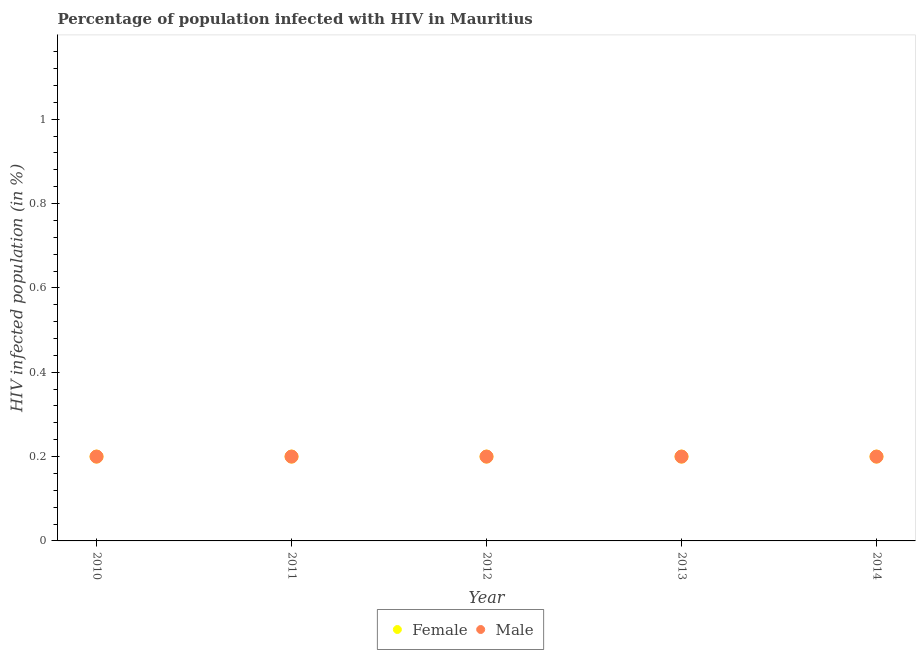Is the number of dotlines equal to the number of legend labels?
Offer a terse response. Yes. Across all years, what is the minimum percentage of females who are infected with hiv?
Provide a succinct answer. 0.2. What is the difference between the percentage of males who are infected with hiv in 2010 and the percentage of females who are infected with hiv in 2012?
Make the answer very short. 0. What is the average percentage of males who are infected with hiv per year?
Provide a succinct answer. 0.2. What is the ratio of the percentage of females who are infected with hiv in 2011 to that in 2014?
Offer a very short reply. 1. Is the percentage of females who are infected with hiv in 2011 less than that in 2014?
Offer a very short reply. No. What is the difference between the highest and the second highest percentage of males who are infected with hiv?
Provide a short and direct response. 0. Is the percentage of females who are infected with hiv strictly less than the percentage of males who are infected with hiv over the years?
Your answer should be very brief. No. How many dotlines are there?
Your answer should be very brief. 2. Are the values on the major ticks of Y-axis written in scientific E-notation?
Give a very brief answer. No. Does the graph contain grids?
Offer a very short reply. No. Where does the legend appear in the graph?
Keep it short and to the point. Bottom center. What is the title of the graph?
Offer a terse response. Percentage of population infected with HIV in Mauritius. Does "2012 US$" appear as one of the legend labels in the graph?
Your answer should be compact. No. What is the label or title of the Y-axis?
Make the answer very short. HIV infected population (in %). What is the HIV infected population (in %) in Female in 2010?
Provide a short and direct response. 0.2. What is the HIV infected population (in %) in Male in 2010?
Provide a succinct answer. 0.2. What is the HIV infected population (in %) of Male in 2011?
Give a very brief answer. 0.2. What is the HIV infected population (in %) in Female in 2012?
Keep it short and to the point. 0.2. What is the HIV infected population (in %) in Male in 2012?
Your response must be concise. 0.2. What is the HIV infected population (in %) in Male in 2014?
Keep it short and to the point. 0.2. Across all years, what is the maximum HIV infected population (in %) in Female?
Your answer should be compact. 0.2. Across all years, what is the maximum HIV infected population (in %) in Male?
Ensure brevity in your answer.  0.2. Across all years, what is the minimum HIV infected population (in %) in Female?
Provide a short and direct response. 0.2. Across all years, what is the minimum HIV infected population (in %) of Male?
Provide a succinct answer. 0.2. What is the total HIV infected population (in %) of Female in the graph?
Ensure brevity in your answer.  1. What is the difference between the HIV infected population (in %) of Female in 2010 and that in 2013?
Give a very brief answer. 0. What is the difference between the HIV infected population (in %) of Female in 2010 and that in 2014?
Offer a very short reply. 0. What is the difference between the HIV infected population (in %) of Male in 2011 and that in 2013?
Offer a terse response. 0. What is the difference between the HIV infected population (in %) in Female in 2011 and that in 2014?
Offer a terse response. 0. What is the difference between the HIV infected population (in %) of Female in 2012 and that in 2013?
Give a very brief answer. 0. What is the difference between the HIV infected population (in %) in Male in 2012 and that in 2013?
Your response must be concise. 0. What is the difference between the HIV infected population (in %) in Female in 2012 and that in 2014?
Provide a short and direct response. 0. What is the difference between the HIV infected population (in %) of Male in 2013 and that in 2014?
Ensure brevity in your answer.  0. What is the difference between the HIV infected population (in %) in Female in 2010 and the HIV infected population (in %) in Male in 2011?
Keep it short and to the point. 0. What is the difference between the HIV infected population (in %) in Female in 2010 and the HIV infected population (in %) in Male in 2014?
Offer a terse response. 0. What is the difference between the HIV infected population (in %) in Female in 2011 and the HIV infected population (in %) in Male in 2012?
Offer a terse response. 0. What is the difference between the HIV infected population (in %) in Female in 2011 and the HIV infected population (in %) in Male in 2013?
Your answer should be compact. 0. What is the difference between the HIV infected population (in %) in Female in 2011 and the HIV infected population (in %) in Male in 2014?
Your answer should be very brief. 0. What is the difference between the HIV infected population (in %) of Female in 2012 and the HIV infected population (in %) of Male in 2013?
Offer a terse response. 0. What is the difference between the HIV infected population (in %) in Female in 2012 and the HIV infected population (in %) in Male in 2014?
Offer a terse response. 0. What is the difference between the HIV infected population (in %) in Female in 2013 and the HIV infected population (in %) in Male in 2014?
Ensure brevity in your answer.  0. What is the average HIV infected population (in %) of Female per year?
Keep it short and to the point. 0.2. What is the average HIV infected population (in %) of Male per year?
Give a very brief answer. 0.2. In the year 2011, what is the difference between the HIV infected population (in %) in Female and HIV infected population (in %) in Male?
Keep it short and to the point. 0. In the year 2013, what is the difference between the HIV infected population (in %) in Female and HIV infected population (in %) in Male?
Offer a very short reply. 0. What is the ratio of the HIV infected population (in %) of Female in 2010 to that in 2011?
Offer a terse response. 1. What is the ratio of the HIV infected population (in %) in Male in 2010 to that in 2012?
Your answer should be very brief. 1. What is the ratio of the HIV infected population (in %) of Female in 2010 to that in 2013?
Give a very brief answer. 1. What is the ratio of the HIV infected population (in %) in Male in 2010 to that in 2013?
Ensure brevity in your answer.  1. What is the ratio of the HIV infected population (in %) in Female in 2010 to that in 2014?
Give a very brief answer. 1. What is the ratio of the HIV infected population (in %) of Male in 2010 to that in 2014?
Offer a very short reply. 1. What is the ratio of the HIV infected population (in %) of Male in 2011 to that in 2013?
Keep it short and to the point. 1. What is the ratio of the HIV infected population (in %) in Female in 2011 to that in 2014?
Your response must be concise. 1. What is the ratio of the HIV infected population (in %) in Male in 2011 to that in 2014?
Your answer should be very brief. 1. What is the ratio of the HIV infected population (in %) of Female in 2012 to that in 2013?
Your response must be concise. 1. What is the ratio of the HIV infected population (in %) in Male in 2013 to that in 2014?
Provide a short and direct response. 1. What is the difference between the highest and the second highest HIV infected population (in %) of Female?
Offer a very short reply. 0. What is the difference between the highest and the lowest HIV infected population (in %) of Male?
Provide a short and direct response. 0. 